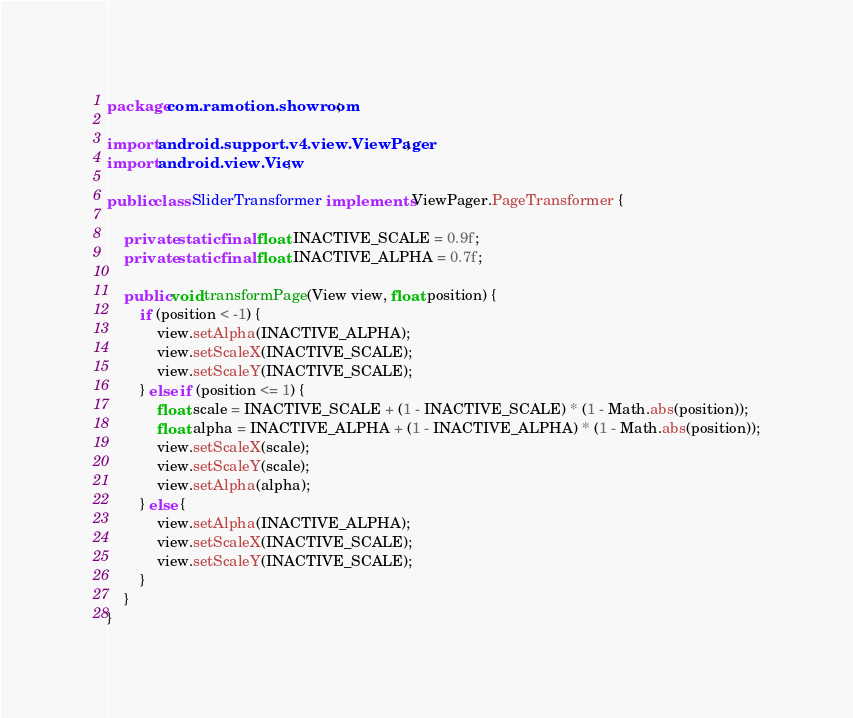Convert code to text. <code><loc_0><loc_0><loc_500><loc_500><_Java_>package com.ramotion.showroom;

import android.support.v4.view.ViewPager;
import android.view.View;

public class SliderTransformer implements ViewPager.PageTransformer {

    private static final float INACTIVE_SCALE = 0.9f;
    private static final float INACTIVE_ALPHA = 0.7f;

    public void transformPage(View view, float position) {
        if (position < -1) {
            view.setAlpha(INACTIVE_ALPHA);
            view.setScaleX(INACTIVE_SCALE);
            view.setScaleY(INACTIVE_SCALE);
        } else if (position <= 1) {
            float scale = INACTIVE_SCALE + (1 - INACTIVE_SCALE) * (1 - Math.abs(position));
            float alpha = INACTIVE_ALPHA + (1 - INACTIVE_ALPHA) * (1 - Math.abs(position));
            view.setScaleX(scale);
            view.setScaleY(scale);
            view.setAlpha(alpha);
        } else {
            view.setAlpha(INACTIVE_ALPHA);
            view.setScaleX(INACTIVE_SCALE);
            view.setScaleY(INACTIVE_SCALE);
        }
    }
}
</code> 